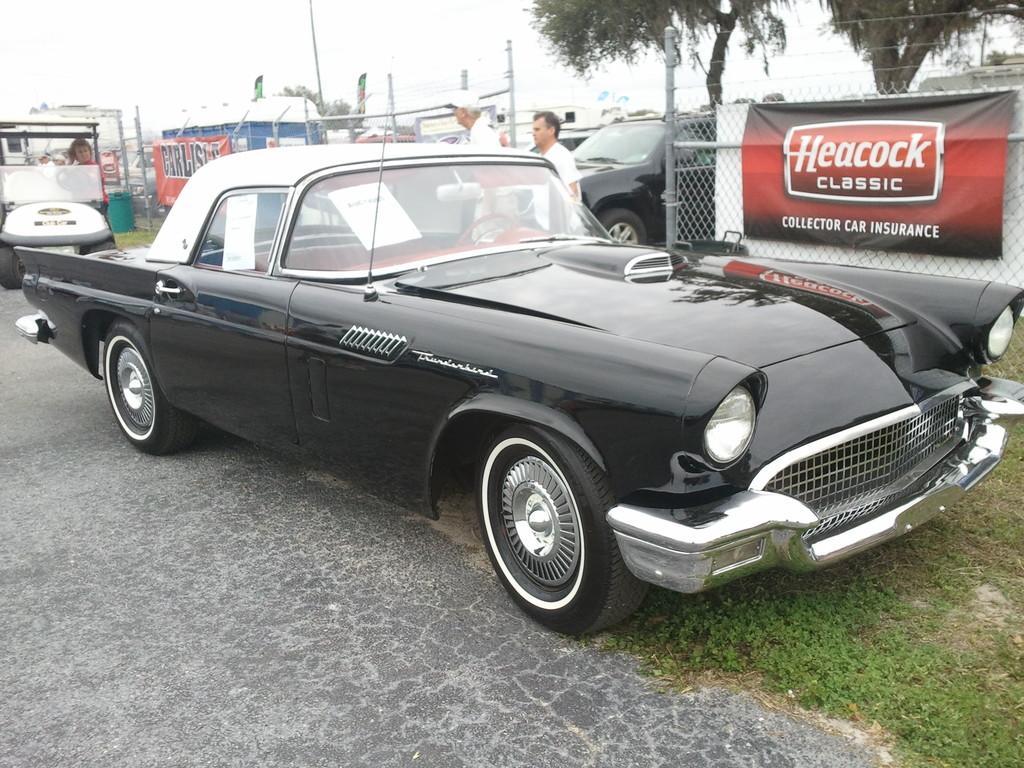How would you summarize this image in a sentence or two? In this image I can see a black car in the front. There are fences and banners on them. There are other cars at the back. There are trees on the right and there is sky at the top. 